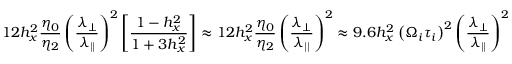Convert formula to latex. <formula><loc_0><loc_0><loc_500><loc_500>1 2 h _ { x } ^ { 2 } \frac { \eta _ { 0 } } { \eta _ { 2 } } \left ( \frac { \lambda _ { \perp } } { \lambda _ { | | } } \right ) ^ { 2 } \left [ \frac { 1 - h _ { x } ^ { 2 } } { 1 + 3 h _ { x } ^ { 2 } } \right ] \approx 1 2 h _ { x } ^ { 2 } \frac { \eta _ { 0 } } { \eta _ { 2 } } \left ( \frac { \lambda _ { \perp } } { \lambda _ { | | } } \right ) ^ { 2 } \approx 9 . 6 h _ { x } ^ { 2 } \left ( \Omega _ { i } \tau _ { i } \right ) ^ { 2 } \left ( \frac { \lambda _ { \perp } } { \lambda _ { | | } } \right ) ^ { 2 } ,</formula> 